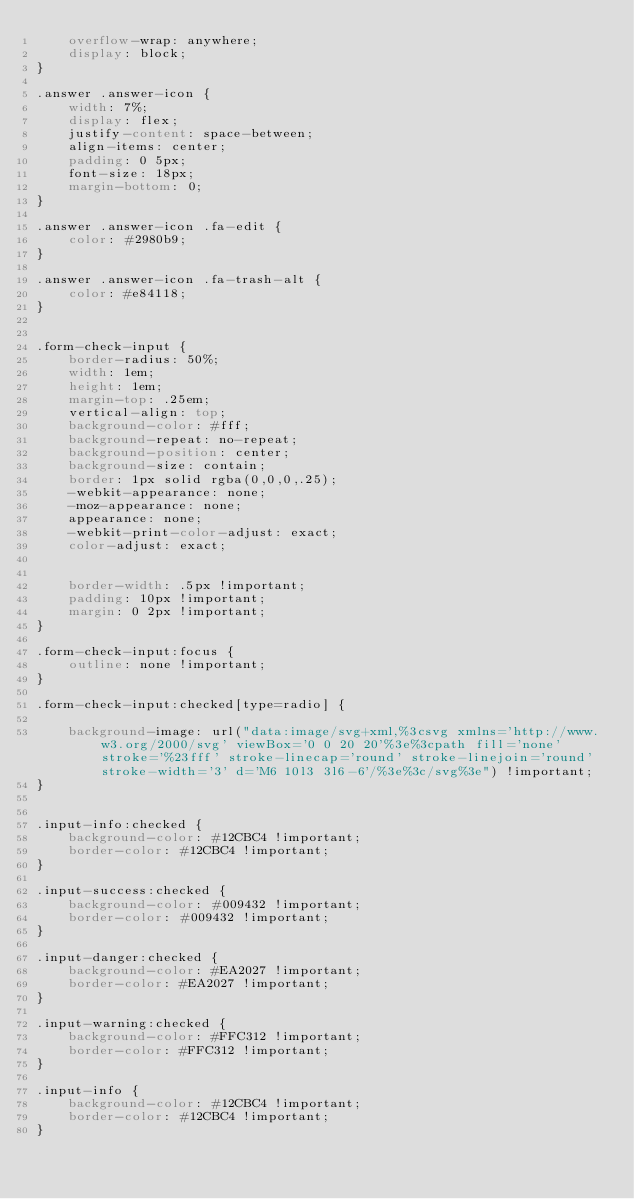<code> <loc_0><loc_0><loc_500><loc_500><_CSS_>    overflow-wrap: anywhere;
    display: block;
}

.answer .answer-icon {
    width: 7%;
    display: flex;
    justify-content: space-between;
    align-items: center;
    padding: 0 5px;
    font-size: 18px;
    margin-bottom: 0;
}

.answer .answer-icon .fa-edit {
    color: #2980b9;
}

.answer .answer-icon .fa-trash-alt {
    color: #e84118;
}


.form-check-input {
    border-radius: 50%;
    width: 1em;
    height: 1em;
    margin-top: .25em;
    vertical-align: top;
    background-color: #fff;
    background-repeat: no-repeat;
    background-position: center;
    background-size: contain;
    border: 1px solid rgba(0,0,0,.25);
    -webkit-appearance: none;
    -moz-appearance: none;
    appearance: none;
    -webkit-print-color-adjust: exact;
    color-adjust: exact;


    border-width: .5px !important;
    padding: 10px !important;
    margin: 0 2px !important;
}

.form-check-input:focus {
    outline: none !important;
}

.form-check-input:checked[type=radio] {
    
    background-image: url("data:image/svg+xml,%3csvg xmlns='http://www.w3.org/2000/svg' viewBox='0 0 20 20'%3e%3cpath fill='none' stroke='%23fff' stroke-linecap='round' stroke-linejoin='round' stroke-width='3' d='M6 10l3 3l6-6'/%3e%3c/svg%3e") !important;
}


.input-info:checked {
    background-color: #12CBC4 !important;
    border-color: #12CBC4 !important;
}

.input-success:checked {
    background-color: #009432 !important;
    border-color: #009432 !important;
}

.input-danger:checked {
    background-color: #EA2027 !important;
    border-color: #EA2027 !important;
}

.input-warning:checked {
    background-color: #FFC312 !important;
    border-color: #FFC312 !important;
}

.input-info {
    background-color: #12CBC4 !important;
    border-color: #12CBC4 !important;
}
</code> 